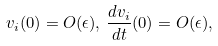<formula> <loc_0><loc_0><loc_500><loc_500>v _ { i } ( 0 ) = O ( \epsilon ) , \, \frac { d v _ { i } } { d t } ( 0 ) = O ( \epsilon ) ,</formula> 